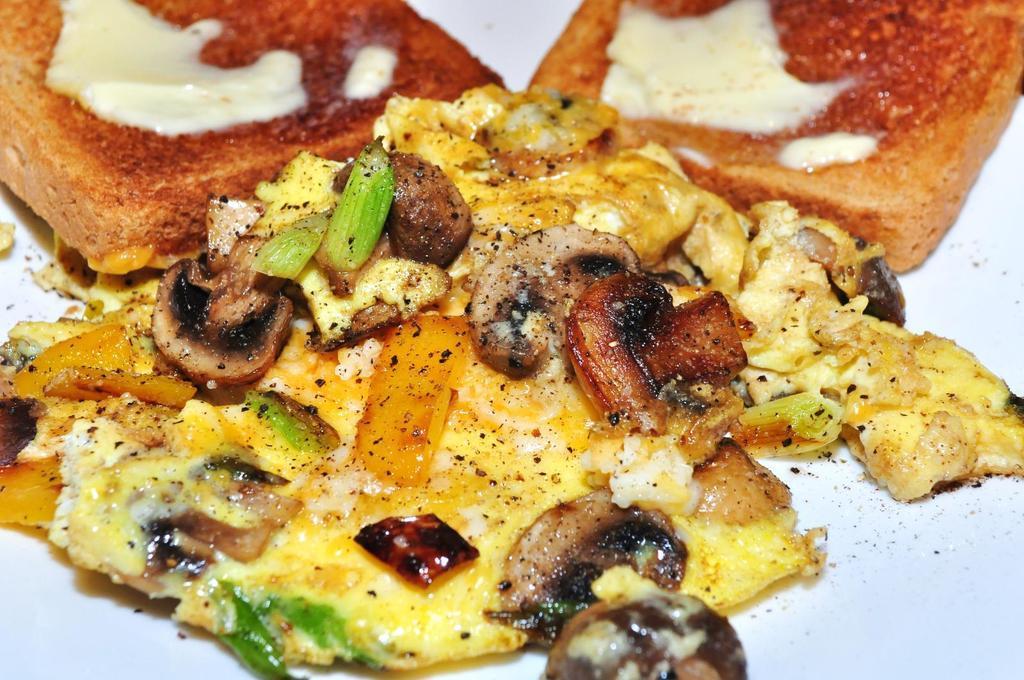Can you describe this image briefly? In this image we can see some food on an object, which looks like a plate. 